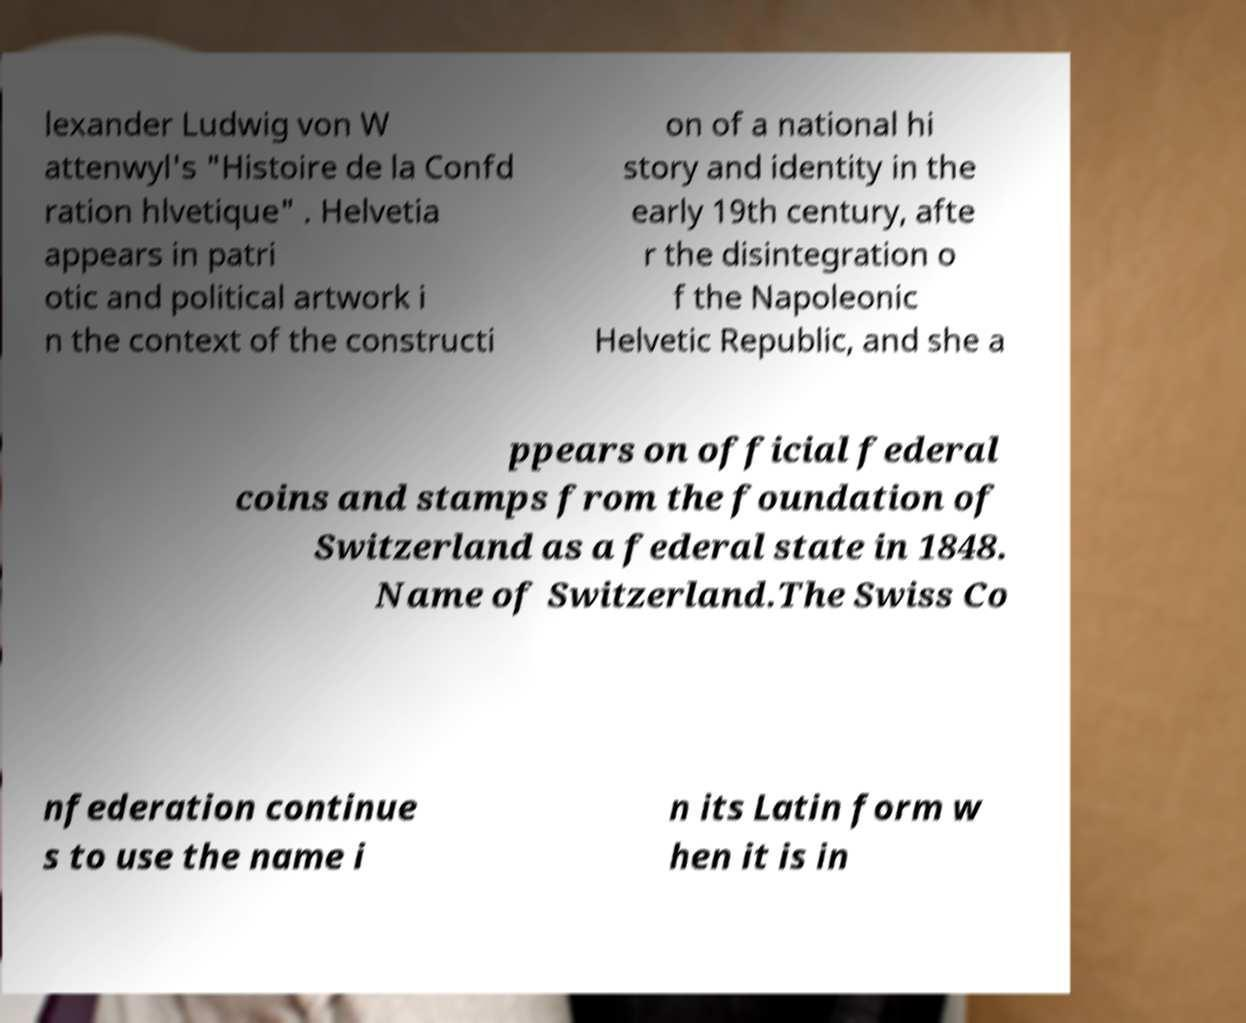Can you read and provide the text displayed in the image?This photo seems to have some interesting text. Can you extract and type it out for me? lexander Ludwig von W attenwyl's "Histoire de la Confd ration hlvetique" . Helvetia appears in patri otic and political artwork i n the context of the constructi on of a national hi story and identity in the early 19th century, afte r the disintegration o f the Napoleonic Helvetic Republic, and she a ppears on official federal coins and stamps from the foundation of Switzerland as a federal state in 1848. Name of Switzerland.The Swiss Co nfederation continue s to use the name i n its Latin form w hen it is in 